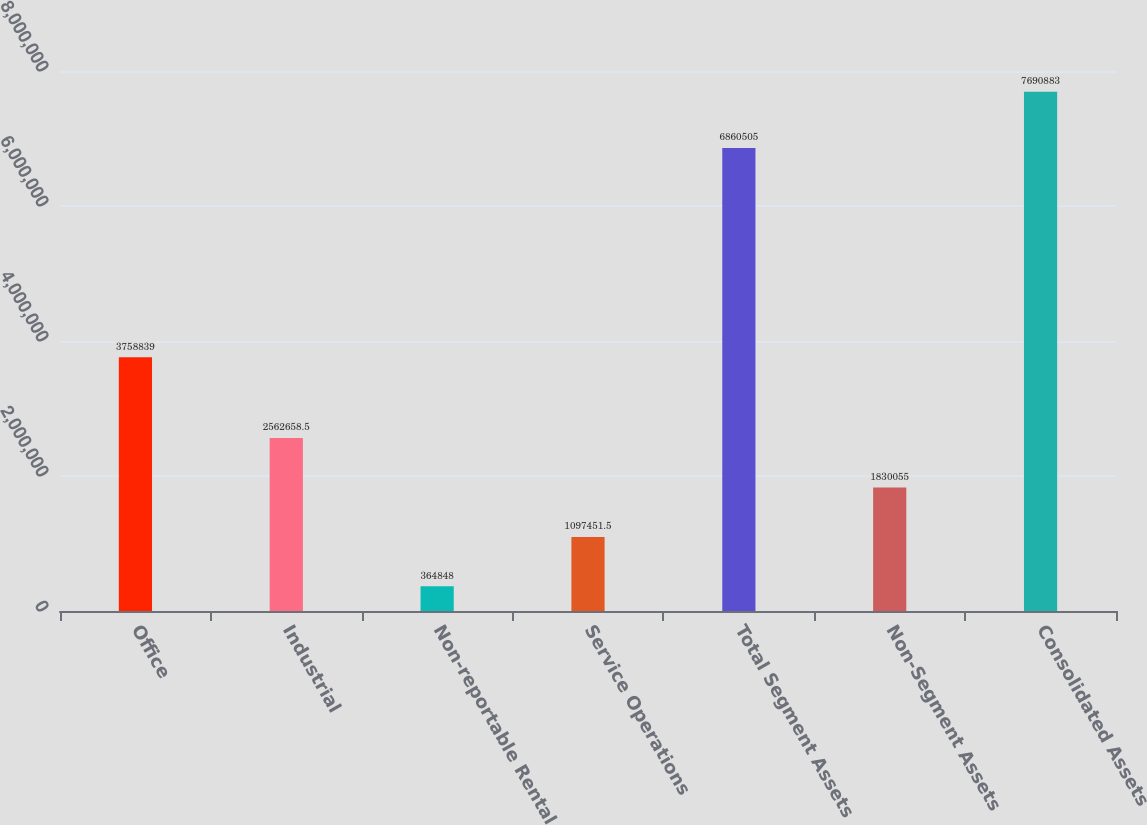Convert chart. <chart><loc_0><loc_0><loc_500><loc_500><bar_chart><fcel>Office<fcel>Industrial<fcel>Non-reportable Rental<fcel>Service Operations<fcel>Total Segment Assets<fcel>Non-Segment Assets<fcel>Consolidated Assets<nl><fcel>3.75884e+06<fcel>2.56266e+06<fcel>364848<fcel>1.09745e+06<fcel>6.8605e+06<fcel>1.83006e+06<fcel>7.69088e+06<nl></chart> 